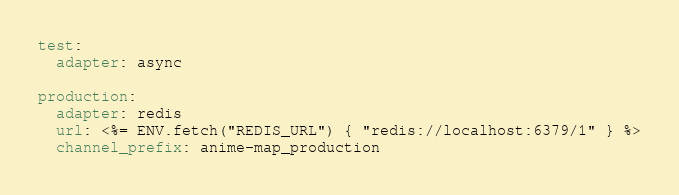Convert code to text. <code><loc_0><loc_0><loc_500><loc_500><_YAML_>test:
  adapter: async

production:
  adapter: redis
  url: <%= ENV.fetch("REDIS_URL") { "redis://localhost:6379/1" } %>
  channel_prefix: anime-map_production
</code> 